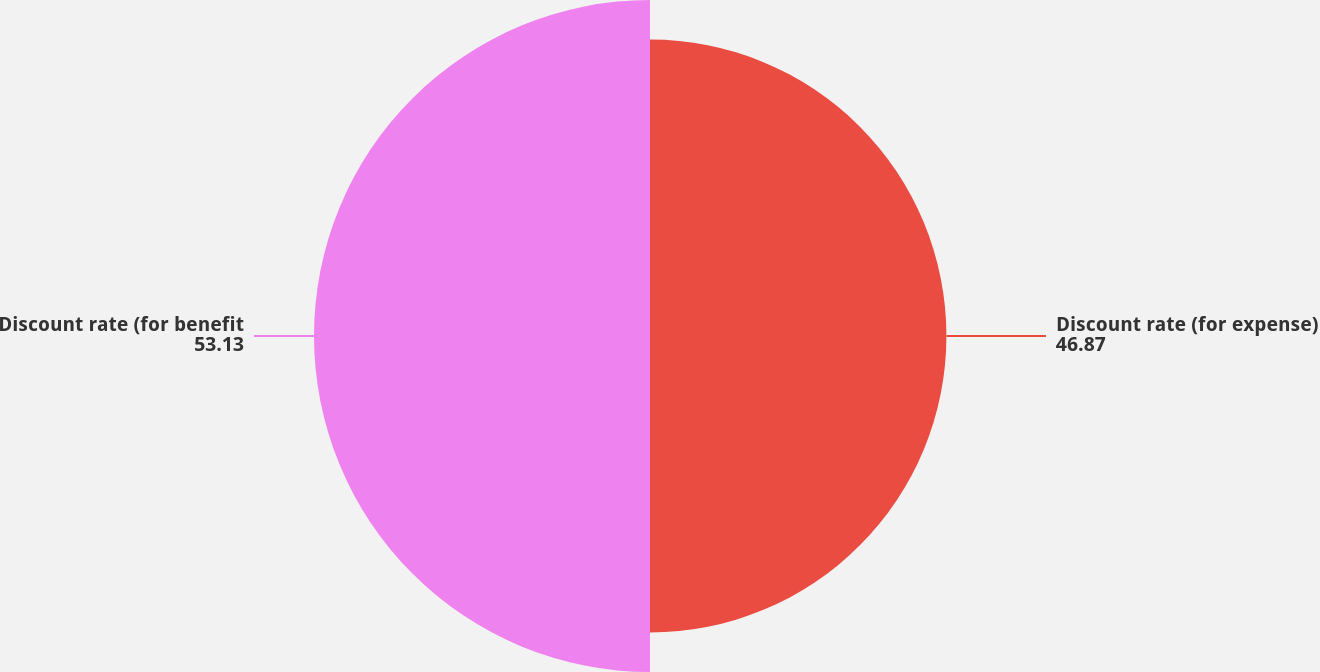Convert chart. <chart><loc_0><loc_0><loc_500><loc_500><pie_chart><fcel>Discount rate (for expense)<fcel>Discount rate (for benefit<nl><fcel>46.87%<fcel>53.13%<nl></chart> 